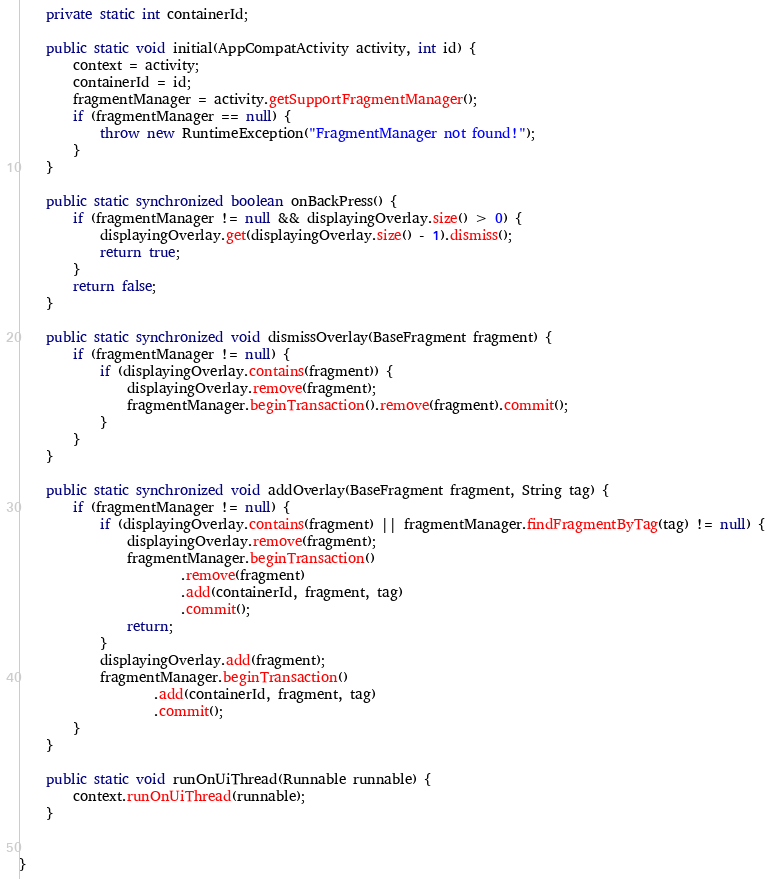<code> <loc_0><loc_0><loc_500><loc_500><_Java_>
    private static int containerId;

    public static void initial(AppCompatActivity activity, int id) {
        context = activity;
        containerId = id;
        fragmentManager = activity.getSupportFragmentManager();
        if (fragmentManager == null) {
            throw new RuntimeException("FragmentManager not found!");
        }
    }

    public static synchronized boolean onBackPress() {
        if (fragmentManager != null && displayingOverlay.size() > 0) {
            displayingOverlay.get(displayingOverlay.size() - 1).dismiss();
            return true;
        }
        return false;
    }

    public static synchronized void dismissOverlay(BaseFragment fragment) {
        if (fragmentManager != null) {
            if (displayingOverlay.contains(fragment)) {
                displayingOverlay.remove(fragment);
                fragmentManager.beginTransaction().remove(fragment).commit();
            }
        }
    }

    public static synchronized void addOverlay(BaseFragment fragment, String tag) {
        if (fragmentManager != null) {
            if (displayingOverlay.contains(fragment) || fragmentManager.findFragmentByTag(tag) != null) {
                displayingOverlay.remove(fragment);
                fragmentManager.beginTransaction()
                        .remove(fragment)
                        .add(containerId, fragment, tag)
                        .commit();
                return;
            }
            displayingOverlay.add(fragment);
            fragmentManager.beginTransaction()
                    .add(containerId, fragment, tag)
                    .commit();
        }
    }

    public static void runOnUiThread(Runnable runnable) {
        context.runOnUiThread(runnable);
    }


}
</code> 